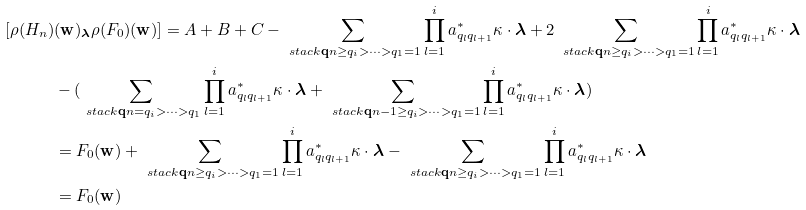Convert formula to latex. <formula><loc_0><loc_0><loc_500><loc_500>[ \rho ( H _ { n } ) & ( \mathbf w ) _ { \boldsymbol \lambda } \rho ( F _ { 0 } ) ( \mathbf w ) ] = A + B + C - \sum _ { \ s t a c k { \mathbf q } { n \geq q _ { i } > \cdots > q _ { 1 } = 1 } } \prod _ { l = 1 } ^ { i } a _ { q _ { l } q _ { l + 1 } } ^ { * } \kappa \cdot { \boldsymbol \lambda } + 2 \sum _ { \ s t a c k { \mathbf q } { n \geq q _ { i } > \cdots > q _ { 1 } = 1 } } \prod _ { l = 1 } ^ { i } a _ { q _ { l } q _ { l + 1 } } ^ { * } \kappa \cdot { \boldsymbol \lambda } \\ & - ( \sum _ { \ s t a c k { \mathbf q } { n = q _ { i } > \cdots > q _ { 1 } } } \prod _ { l = 1 } ^ { i } a _ { q _ { l } q _ { l + 1 } } ^ { * } \kappa \cdot { \boldsymbol \lambda } + \sum _ { \ s t a c k { \mathbf q } { n - 1 \geq q _ { i } > \cdots > q _ { 1 } = 1 } } \prod _ { l = 1 } ^ { i } a _ { q _ { l } q _ { l + 1 } } ^ { * } \kappa \cdot { \boldsymbol \lambda } ) \\ & = F _ { 0 } ( \mathbf w ) + \sum _ { \ s t a c k { \mathbf q } { n \geq q _ { i } > \cdots > q _ { 1 } = 1 } } \prod _ { l = 1 } ^ { i } a _ { q _ { l } q _ { l + 1 } } ^ { * } \kappa \cdot { \boldsymbol \lambda } - \sum _ { \ s t a c k { \mathbf q } { n \geq q _ { i } > \cdots > q _ { 1 } = 1 } } \prod _ { l = 1 } ^ { i } a _ { q _ { l } q _ { l + 1 } } ^ { * } \kappa \cdot { \boldsymbol \lambda } \\ & = F _ { 0 } ( \mathbf w )</formula> 